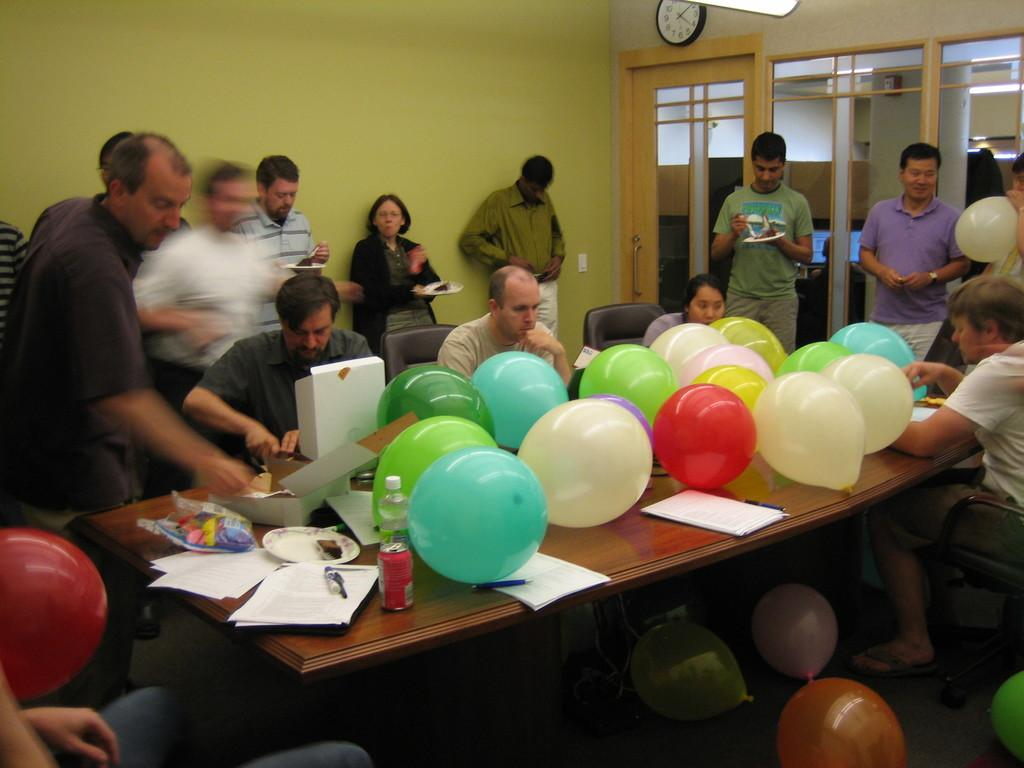How many people are in the image? There are people in the image, but the exact number is not specified. What are the people in the image doing? Some people are sitting, while others are standing. What objects can be seen on a table in the image? There are balloons on a table in the image. What is on the wall in the image? There is a clock on a wall in the image. How many protest signs can be seen on the sidewalk in the image? There is no mention of protest signs or a sidewalk in the image; the facts only mention people, balloons, and a clock. 